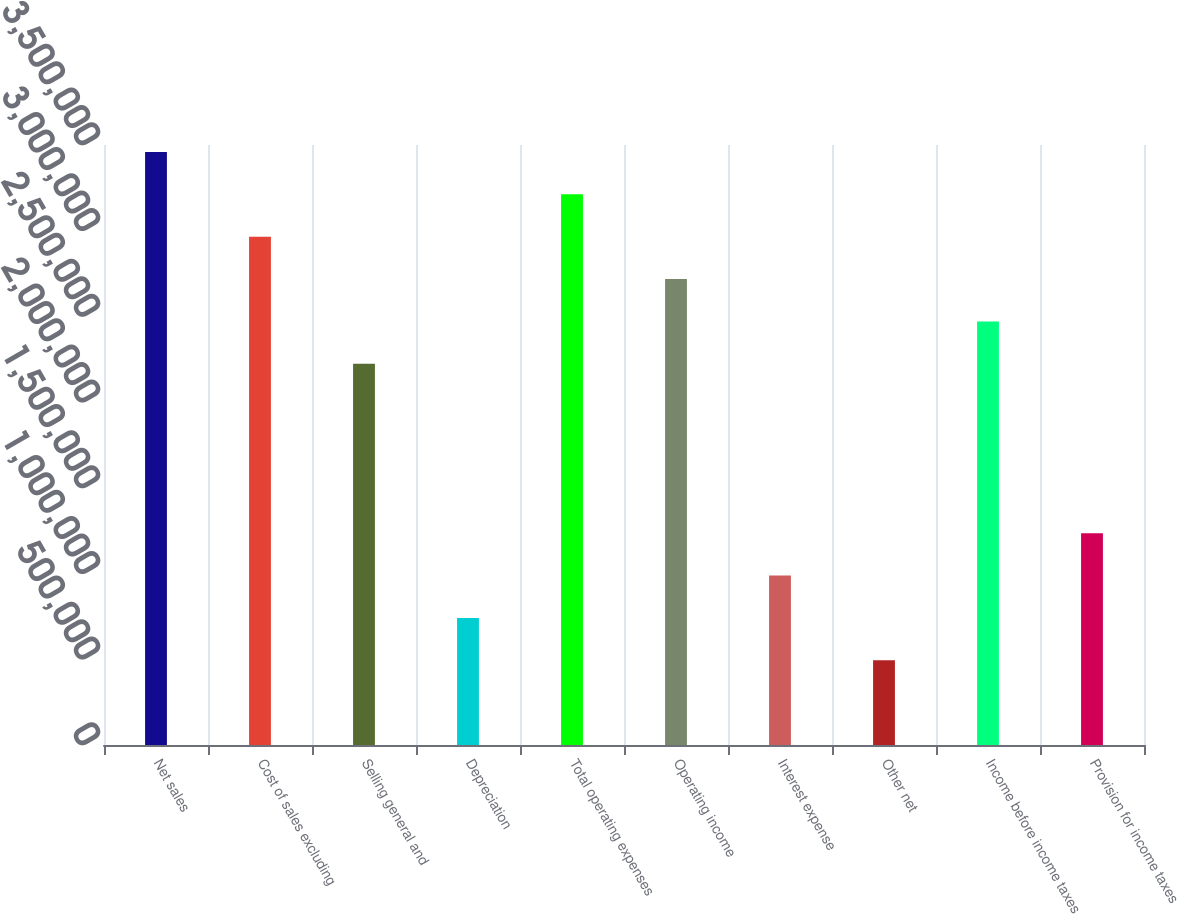Convert chart to OTSL. <chart><loc_0><loc_0><loc_500><loc_500><bar_chart><fcel>Net sales<fcel>Cost of sales excluding<fcel>Selling general and<fcel>Depreciation<fcel>Total operating expenses<fcel>Operating income<fcel>Interest expense<fcel>Other net<fcel>Income before income taxes<fcel>Provision for income taxes<nl><fcel>3.45933e+06<fcel>2.96514e+06<fcel>2.22386e+06<fcel>741287<fcel>3.21224e+06<fcel>2.71805e+06<fcel>988382<fcel>494192<fcel>2.47095e+06<fcel>1.23548e+06<nl></chart> 